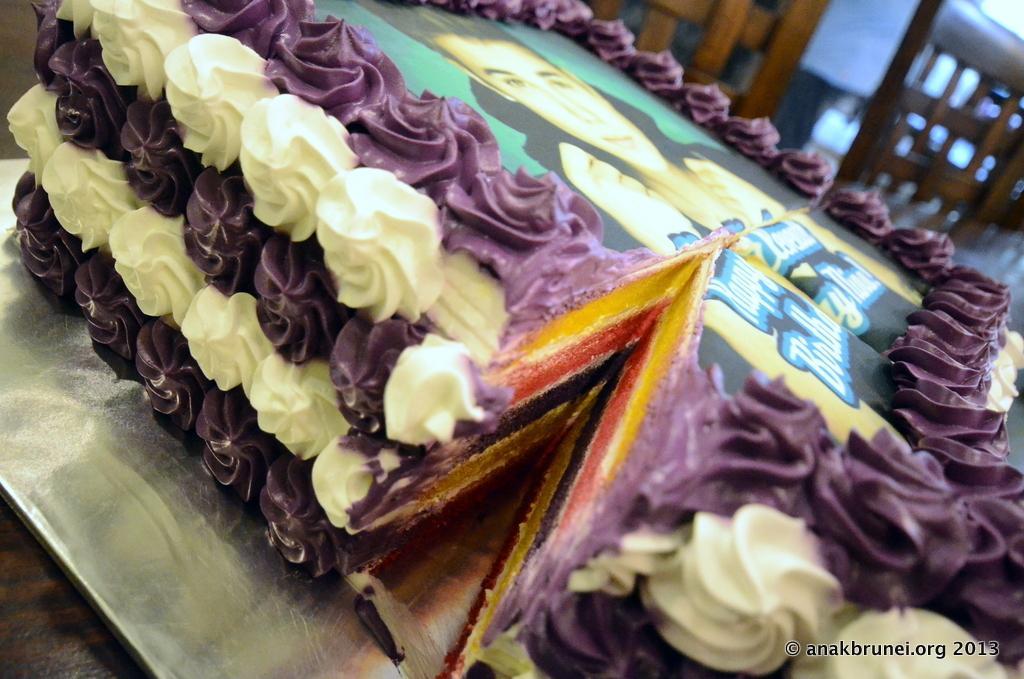How would you summarize this image in a sentence or two? In this image we can see cake on a base. In the back there are wooden objects. In the right bottom corner there is a watermark. 